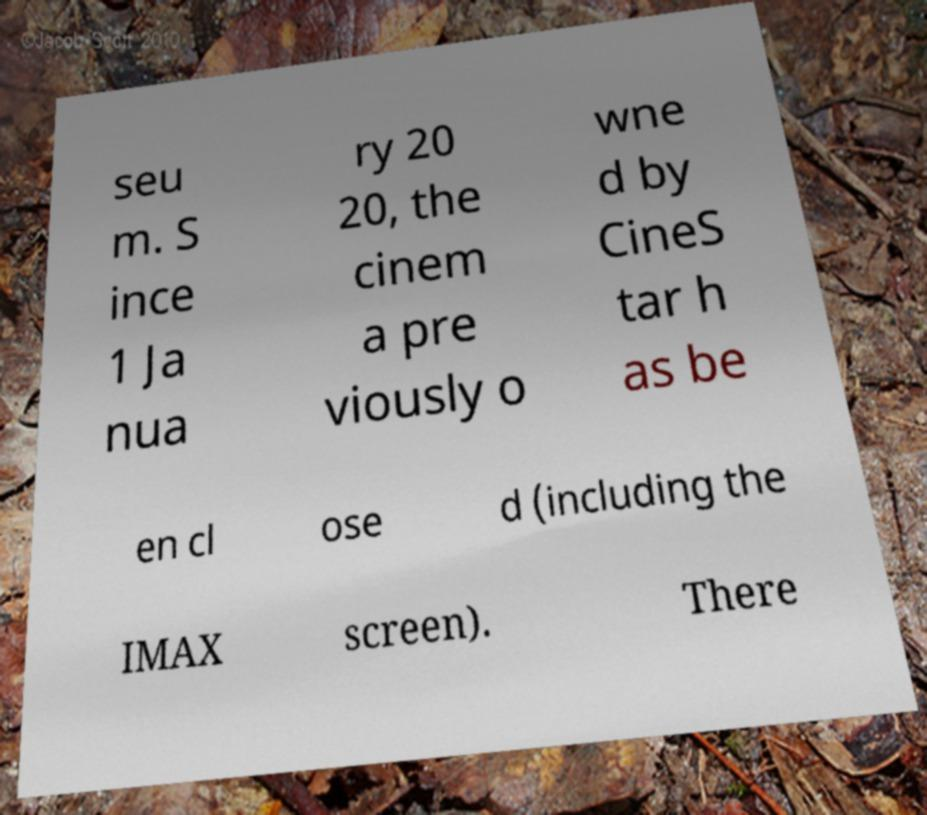Please read and relay the text visible in this image. What does it say? seu m. S ince 1 Ja nua ry 20 20, the cinem a pre viously o wne d by CineS tar h as be en cl ose d (including the IMAX screen). There 